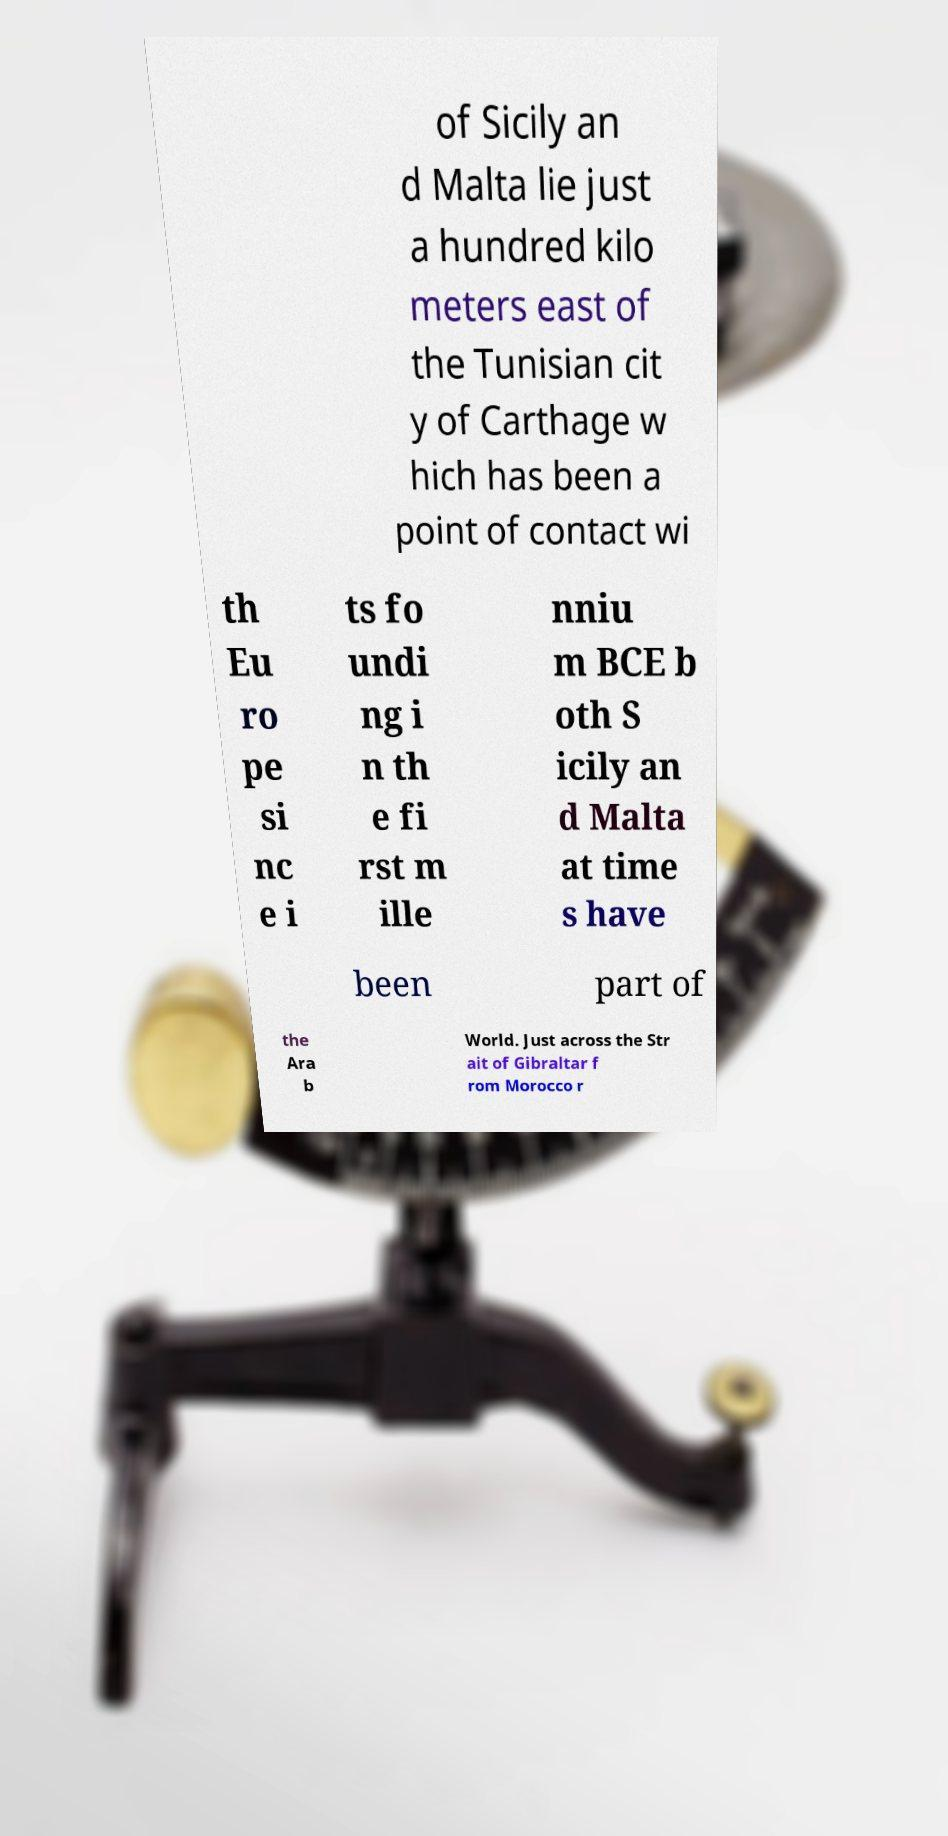Please read and relay the text visible in this image. What does it say? of Sicily an d Malta lie just a hundred kilo meters east of the Tunisian cit y of Carthage w hich has been a point of contact wi th Eu ro pe si nc e i ts fo undi ng i n th e fi rst m ille nniu m BCE b oth S icily an d Malta at time s have been part of the Ara b World. Just across the Str ait of Gibraltar f rom Morocco r 